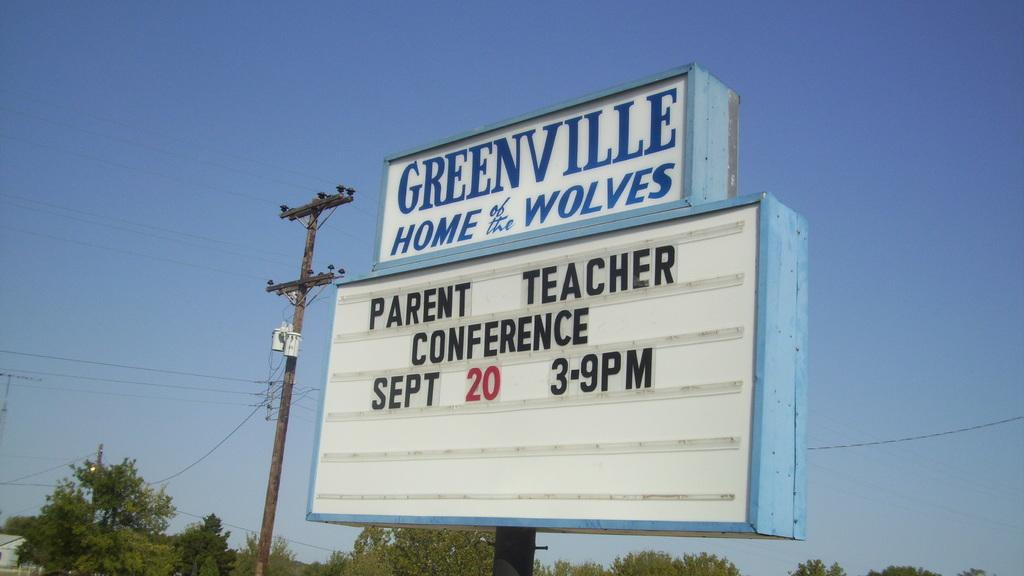<image>
Describe the image concisely. a Greenville sign that has many words under it 